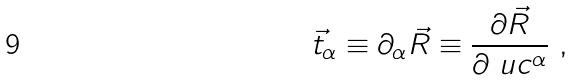<formula> <loc_0><loc_0><loc_500><loc_500>\vec { t } _ { \alpha } \equiv \partial _ { \alpha } \vec { R } \equiv \frac { \partial \vec { R } } { \partial \ u c ^ { \alpha } } \ ,</formula> 